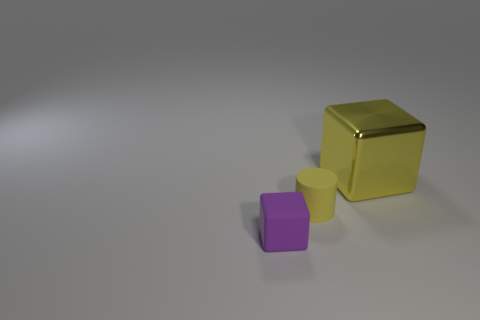Is there any other thing that is the same size as the yellow block?
Keep it short and to the point. No. Is there any other thing that is made of the same material as the yellow block?
Keep it short and to the point. No. Is there anything else that is the same color as the rubber cube?
Offer a terse response. No. There is a cube on the left side of the yellow thing in front of the large yellow object; what is its size?
Provide a succinct answer. Small. The thing that is both on the left side of the large yellow block and behind the rubber block is what color?
Give a very brief answer. Yellow. How many other things are the same size as the metal thing?
Give a very brief answer. 0. Is the size of the rubber block the same as the thing that is behind the small yellow matte cylinder?
Your answer should be very brief. No. The block that is the same size as the yellow cylinder is what color?
Make the answer very short. Purple. How big is the rubber cylinder?
Provide a succinct answer. Small. Are the small object right of the small purple rubber object and the purple thing made of the same material?
Offer a very short reply. Yes. 